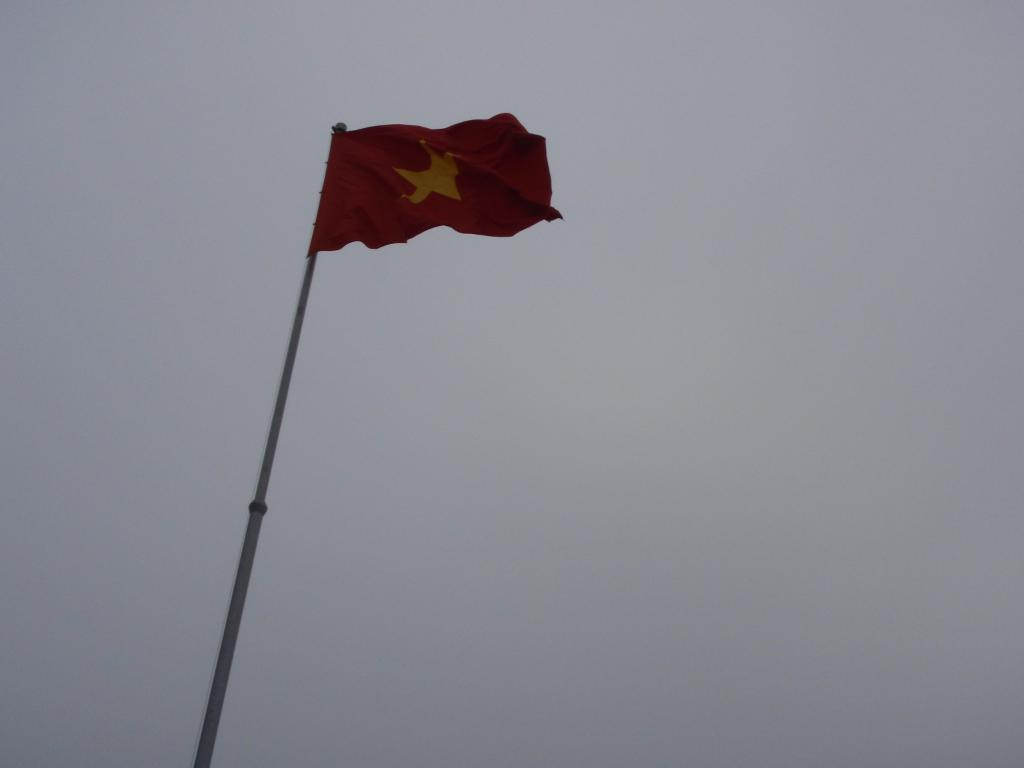What color is the flag in the image? The flag in the image is red. What symbol is present on the flag? The flag has a yellow color star mark on it. How is the flag displayed in the image? The flag is attached to a pole. What is the condition of the sky in the image? The sky is cloudy in the image. What type of cream is being used to paint the gate in the image? There is no gate or cream present in the image; it features a red flag with a yellow star mark on it. What type of humor can be found in the image? There is no humor present in the image; it is a straightforward depiction of a flag. 